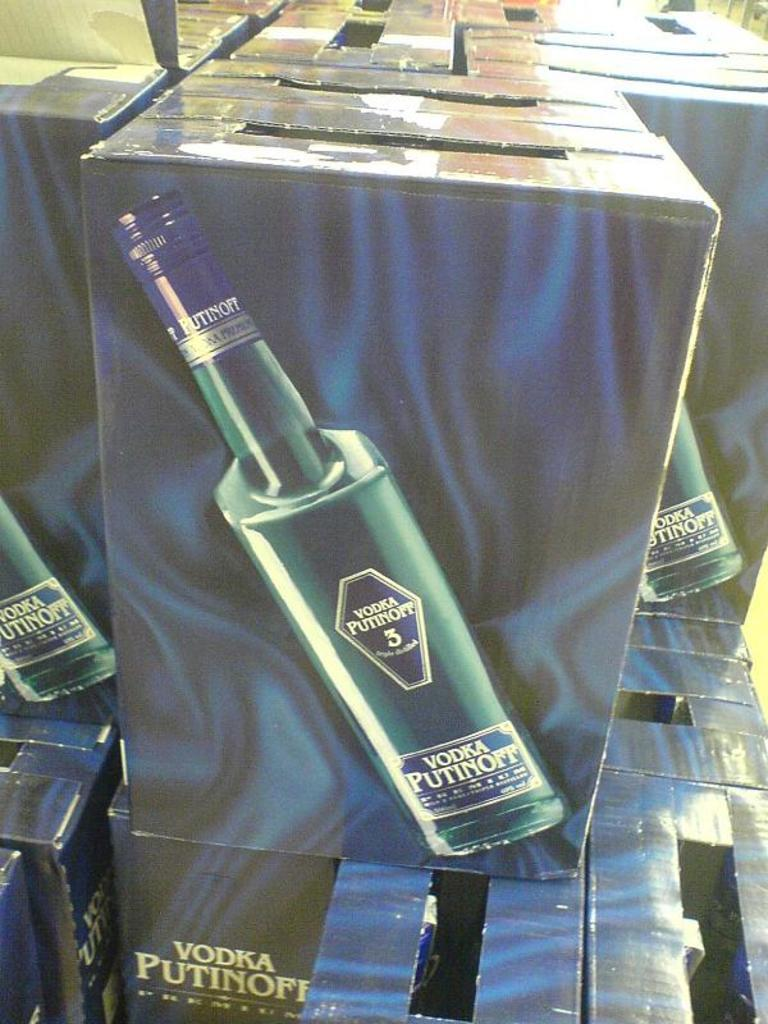<image>
Relay a brief, clear account of the picture shown. Several blue boxes are stacked, containing Vodka Putinoff. 